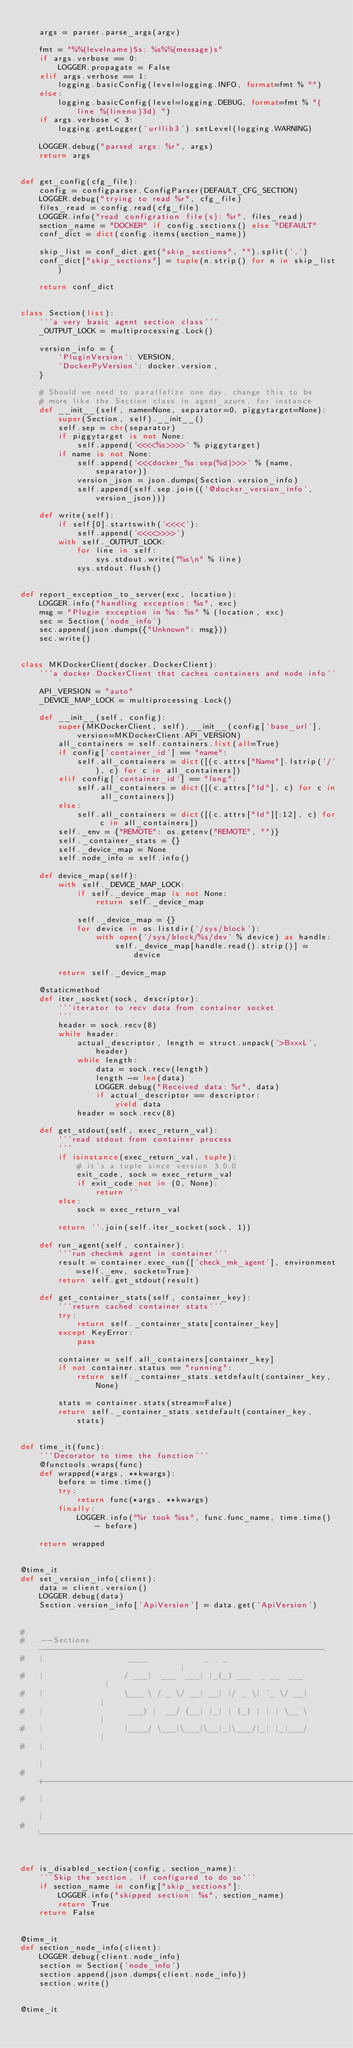<code> <loc_0><loc_0><loc_500><loc_500><_Python_>
    args = parser.parse_args(argv)

    fmt = "%%(levelname)5s: %s%%(message)s"
    if args.verbose == 0:
        LOGGER.propagate = False
    elif args.verbose == 1:
        logging.basicConfig(level=logging.INFO, format=fmt % "")
    else:
        logging.basicConfig(level=logging.DEBUG, format=fmt % "(line %(lineno)3d) ")
    if args.verbose < 3:
        logging.getLogger('urllib3').setLevel(logging.WARNING)

    LOGGER.debug("parsed args: %r", args)
    return args


def get_config(cfg_file):
    config = configparser.ConfigParser(DEFAULT_CFG_SECTION)
    LOGGER.debug("trying to read %r", cfg_file)
    files_read = config.read(cfg_file)
    LOGGER.info("read configration file(s): %r", files_read)
    section_name = "DOCKER" if config.sections() else "DEFAULT"
    conf_dict = dict(config.items(section_name))

    skip_list = conf_dict.get("skip_sections", "").split(',')
    conf_dict["skip_sections"] = tuple(n.strip() for n in skip_list)

    return conf_dict


class Section(list):
    '''a very basic agent section class'''
    _OUTPUT_LOCK = multiprocessing.Lock()

    version_info = {
        'PluginVersion': VERSION,
        'DockerPyVersion': docker.version,
    }

    # Should we need to parallelize one day, change this to be
    # more like the Section class in agent_azure, for instance
    def __init__(self, name=None, separator=0, piggytarget=None):
        super(Section, self).__init__()
        self.sep = chr(separator)
        if piggytarget is not None:
            self.append('<<<<%s>>>>' % piggytarget)
        if name is not None:
            self.append('<<<docker_%s:sep(%d)>>>' % (name, separator))
            version_json = json.dumps(Section.version_info)
            self.append(self.sep.join(('@docker_version_info', version_json)))

    def write(self):
        if self[0].startswith('<<<<'):
            self.append('<<<<>>>>')
        with self._OUTPUT_LOCK:
            for line in self:
                sys.stdout.write("%s\n" % line)
            sys.stdout.flush()


def report_exception_to_server(exc, location):
    LOGGER.info("handling exception: %s", exc)
    msg = "Plugin exception in %s: %s" % (location, exc)
    sec = Section('node_info')
    sec.append(json.dumps({"Unknown": msg}))
    sec.write()


class MKDockerClient(docker.DockerClient):
    '''a docker.DockerClient that caches containers and node info'''
    API_VERSION = "auto"
    _DEVICE_MAP_LOCK = multiprocessing.Lock()

    def __init__(self, config):
        super(MKDockerClient, self).__init__(config['base_url'], version=MKDockerClient.API_VERSION)
        all_containers = self.containers.list(all=True)
        if config['container_id'] == "name":
            self.all_containers = dict([(c.attrs["Name"].lstrip('/'), c) for c in all_containers])
        elif config['container_id'] == "long":
            self.all_containers = dict([(c.attrs["Id"], c) for c in all_containers])
        else:
            self.all_containers = dict([(c.attrs["Id"][:12], c) for c in all_containers])
        self._env = {"REMOTE": os.getenv("REMOTE", "")}
        self._container_stats = {}
        self._device_map = None
        self.node_info = self.info()

    def device_map(self):
        with self._DEVICE_MAP_LOCK:
            if self._device_map is not None:
                return self._device_map

            self._device_map = {}
            for device in os.listdir('/sys/block'):
                with open('/sys/block/%s/dev' % device) as handle:
                    self._device_map[handle.read().strip()] = device

        return self._device_map

    @staticmethod
    def iter_socket(sock, descriptor):
        '''iterator to recv data from container socket
        '''
        header = sock.recv(8)
        while header:
            actual_descriptor, length = struct.unpack('>BxxxL', header)
            while length:
                data = sock.recv(length)
                length -= len(data)
                LOGGER.debug("Received data: %r", data)
                if actual_descriptor == descriptor:
                    yield data
            header = sock.recv(8)

    def get_stdout(self, exec_return_val):
        '''read stdout from container process
        '''
        if isinstance(exec_return_val, tuple):
            # it's a tuple since version 3.0.0
            exit_code, sock = exec_return_val
            if exit_code not in (0, None):
                return ''
        else:
            sock = exec_return_val

        return ''.join(self.iter_socket(sock, 1))

    def run_agent(self, container):
        '''run checkmk agent in container'''
        result = container.exec_run(['check_mk_agent'], environment=self._env, socket=True)
        return self.get_stdout(result)

    def get_container_stats(self, container_key):
        '''return cached container stats'''
        try:
            return self._container_stats[container_key]
        except KeyError:
            pass

        container = self.all_containers[container_key]
        if not container.status == "running":
            return self._container_stats.setdefault(container_key, None)

        stats = container.stats(stream=False)
        return self._container_stats.setdefault(container_key, stats)


def time_it(func):
    '''Decorator to time the function'''
    @functools.wraps(func)
    def wrapped(*args, **kwargs):
        before = time.time()
        try:
            return func(*args, **kwargs)
        finally:
            LOGGER.info("%r took %ss", func.func_name, time.time() - before)

    return wrapped


@time_it
def set_version_info(client):
    data = client.version()
    LOGGER.debug(data)
    Section.version_info['ApiVersion'] = data.get('ApiVersion')


#.
#   .--Sections------------------------------------------------------------.
#   |                  ____            _   _                               |
#   |                 / ___|  ___  ___| |_(_) ___  _ __  ___               |
#   |                 \___ \ / _ \/ __| __| |/ _ \| '_ \/ __|              |
#   |                  ___) |  __/ (__| |_| | (_) | | | \__ \              |
#   |                 |____/ \___|\___|\__|_|\___/|_| |_|___/              |
#   |                                                                      |
#   +----------------------------------------------------------------------+
#   |                                                                      |
#   '----------------------------------------------------------------------'


def is_disabled_section(config, section_name):
    '''Skip the section, if configured to do so'''
    if section_name in config["skip_sections"]:
        LOGGER.info("skipped section: %s", section_name)
        return True
    return False


@time_it
def section_node_info(client):
    LOGGER.debug(client.node_info)
    section = Section('node_info')
    section.append(json.dumps(client.node_info))
    section.write()


@time_it</code> 